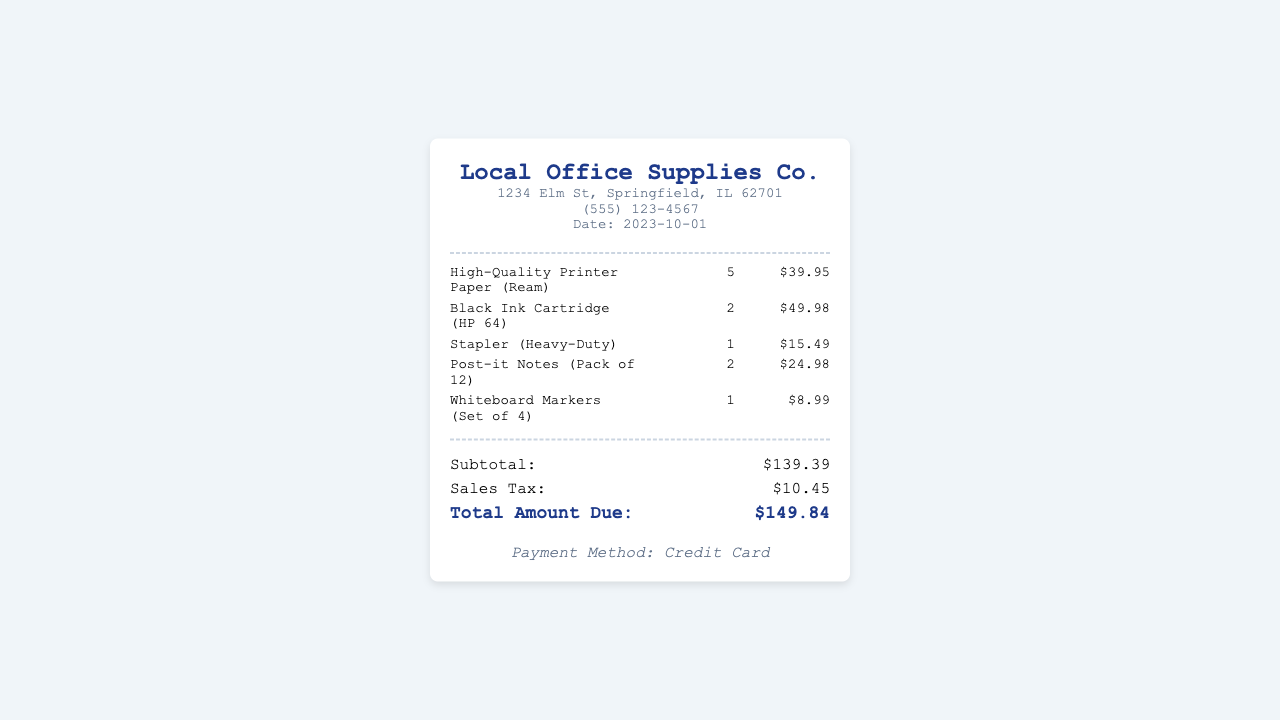What is the vendor name? The vendor name is located at the top of the receipt and indicates who the products were purchased from.
Answer: Local Office Supplies Co What is the date on the receipt? The date is mentioned in the vendor details section and indicates when the purchase occurred.
Answer: 2023-10-01 How many reams of paper were purchased? The quantity of printer paper is listed in the itemized list under the first item description.
Answer: 5 What is the subtotal amount? The subtotal is displayed in the totals section and represents the total cost before tax.
Answer: $139.39 What type of payment method was used? The payment method is mentioned at the bottom of the receipt, indicating how the payment was made.
Answer: Credit Card What is the total amount due? The total amount due is the final figure in the totals section after adding sales tax to the subtotal.
Answer: $149.84 How much was paid in sales tax? The sales tax amount is explicitly listed in the totals section and reflects the tax applied to the purchase.
Answer: $10.45 What is the price of the stapler? The price of the stapler is included in the itemized list, indicating its cost.
Answer: $15.49 How many packs of Post-it Notes were bought? The quantity of Post-it Notes is shown in the item list under its description, indicating how many packs were purchased.
Answer: 2 